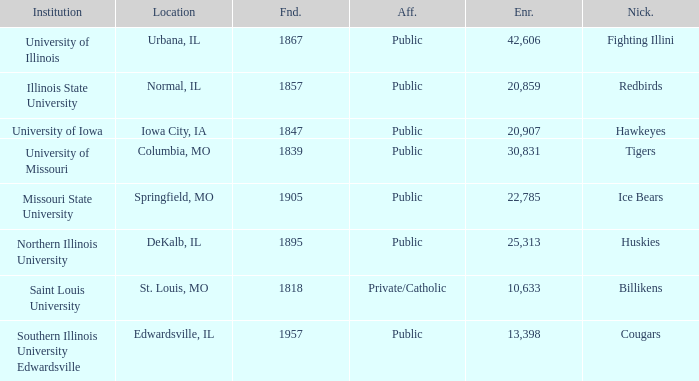Which institution is private/catholic? Saint Louis University. 